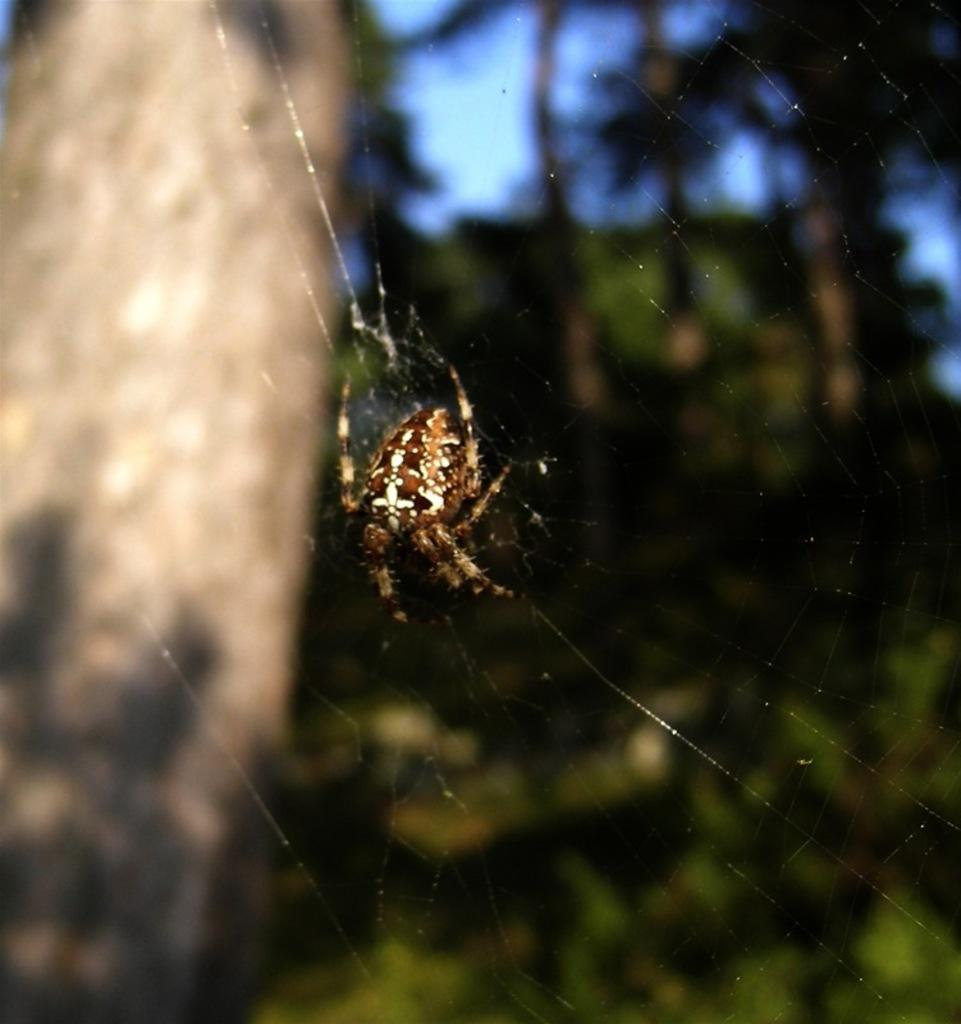What is the main subject of the image? There is a spider in the image. Can you describe the appearance of the spider? The spider is brown and cream in color. What can be seen in the background of the image? There are trees in the background of the image. What is the color of the trees? The trees are green in color. What is the color of the sky in the image? The sky is blue in color. Where is the turkey standing on the stage in the image? There is no turkey or stage present in the image; it features a spider and trees in the background. 